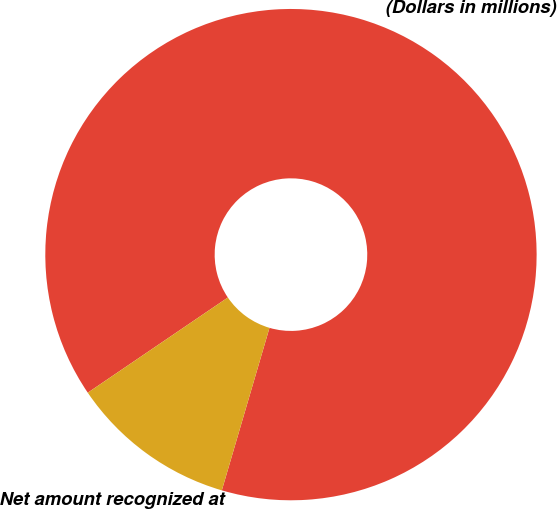<chart> <loc_0><loc_0><loc_500><loc_500><pie_chart><fcel>(Dollars in millions)<fcel>Net amount recognized at<nl><fcel>89.04%<fcel>10.96%<nl></chart> 